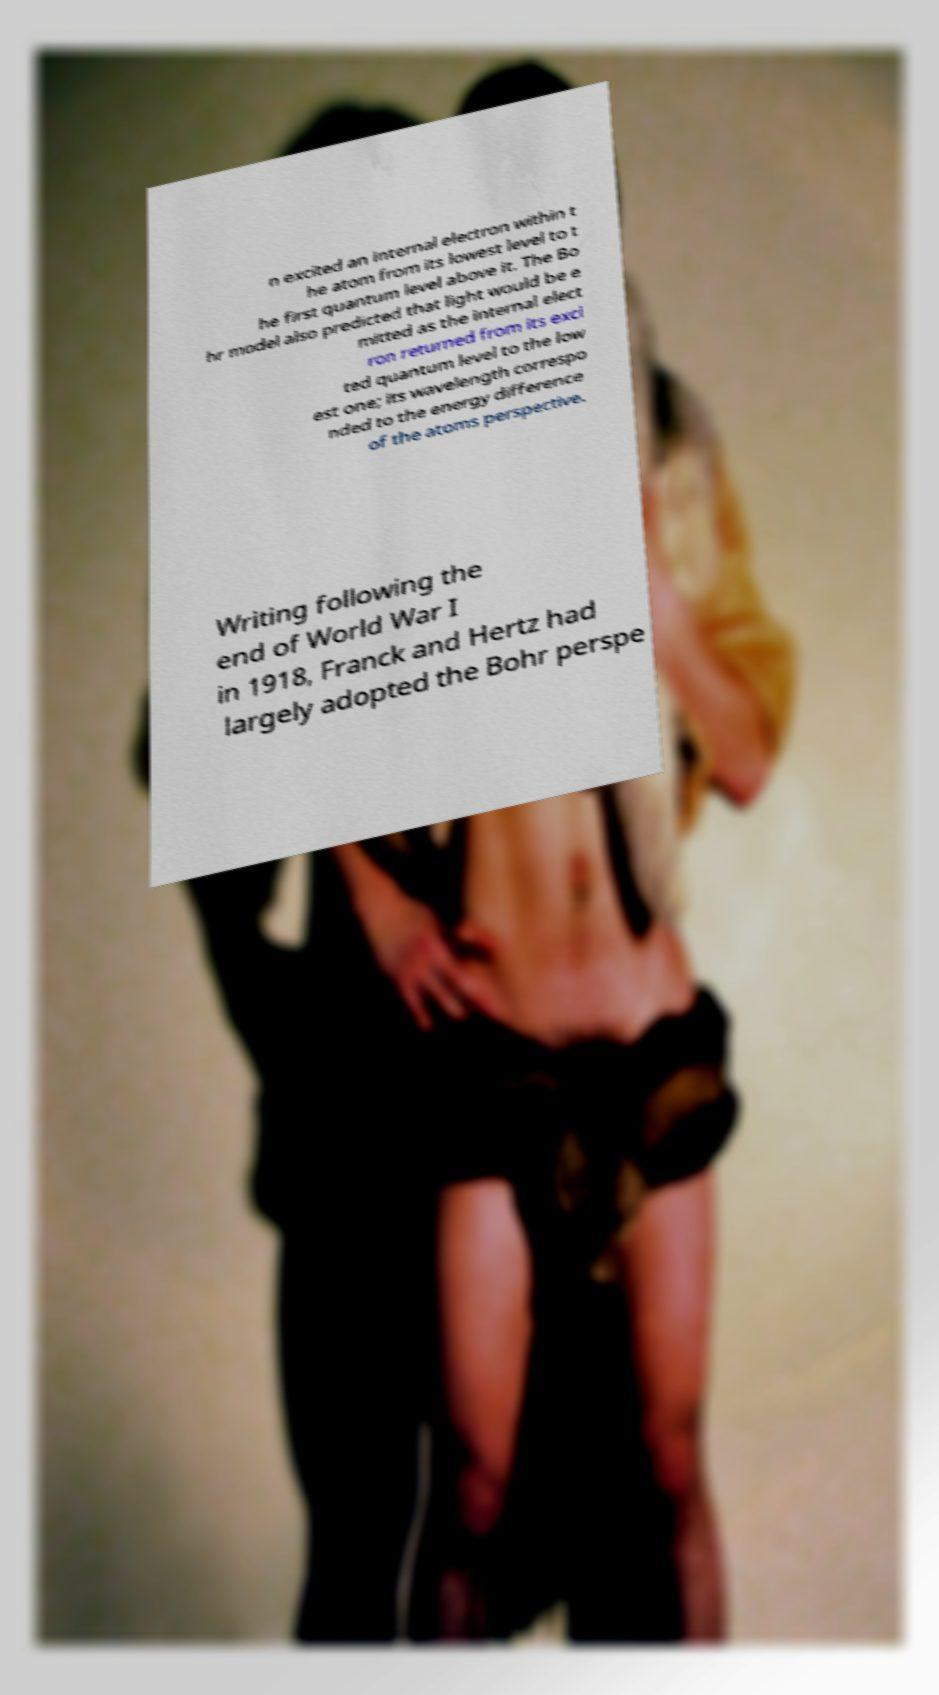Please read and relay the text visible in this image. What does it say? n excited an internal electron within t he atom from its lowest level to t he first quantum level above it. The Bo hr model also predicted that light would be e mitted as the internal elect ron returned from its exci ted quantum level to the low est one; its wavelength correspo nded to the energy difference of the atoms perspective. Writing following the end of World War I in 1918, Franck and Hertz had largely adopted the Bohr perspe 